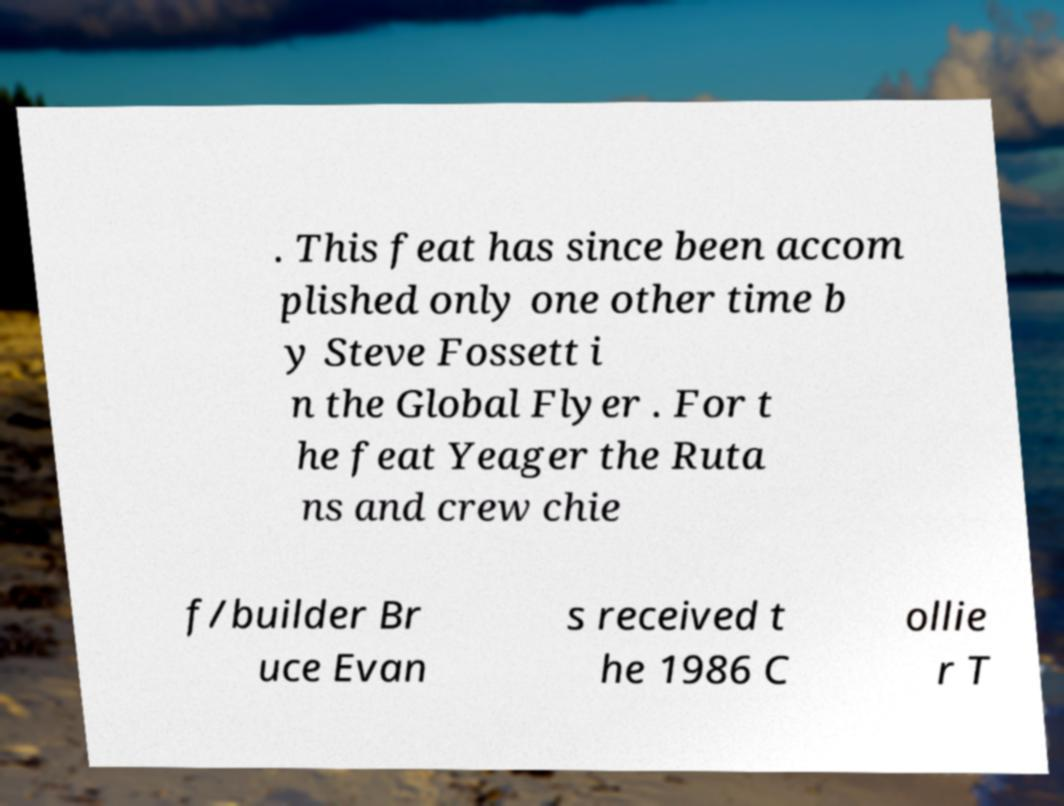Could you extract and type out the text from this image? . This feat has since been accom plished only one other time b y Steve Fossett i n the Global Flyer . For t he feat Yeager the Ruta ns and crew chie f/builder Br uce Evan s received t he 1986 C ollie r T 